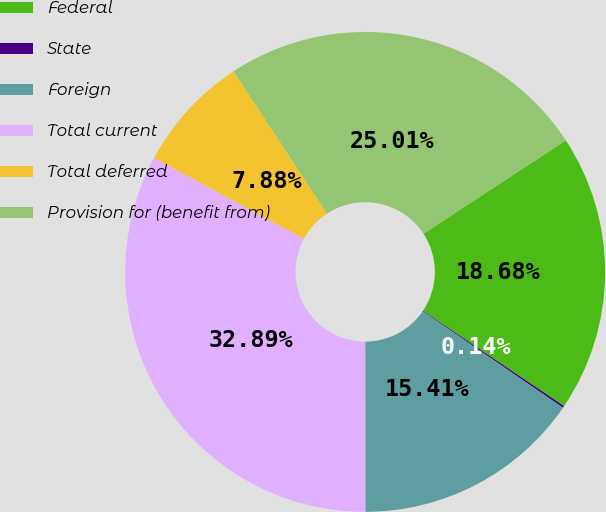Convert chart. <chart><loc_0><loc_0><loc_500><loc_500><pie_chart><fcel>Federal<fcel>State<fcel>Foreign<fcel>Total current<fcel>Total deferred<fcel>Provision for (benefit from)<nl><fcel>18.68%<fcel>0.14%<fcel>15.41%<fcel>32.89%<fcel>7.88%<fcel>25.01%<nl></chart> 